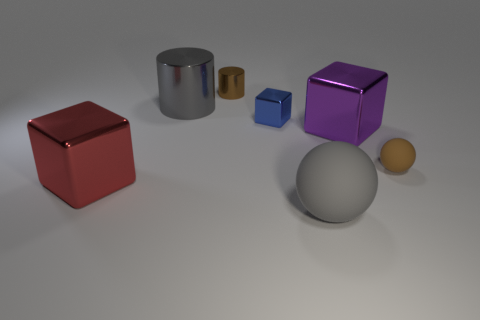What number of metal things are either tiny things or large brown cylinders?
Offer a terse response. 2. What number of other things are the same shape as the tiny blue object?
Ensure brevity in your answer.  2. What material is the large ball that is the same color as the big metallic cylinder?
Provide a succinct answer. Rubber. Do the shiny block that is in front of the tiny rubber object and the cylinder that is to the left of the tiny brown shiny object have the same size?
Provide a succinct answer. Yes. The rubber object behind the large gray matte ball has what shape?
Your response must be concise. Sphere. What is the material of the tiny brown thing that is the same shape as the big gray matte thing?
Give a very brief answer. Rubber. Is the size of the brown object that is in front of the blue shiny thing the same as the large gray ball?
Ensure brevity in your answer.  No. There is a red block; what number of blocks are behind it?
Make the answer very short. 2. Are there fewer small blue shiny objects in front of the big red metal object than big gray things that are right of the big purple thing?
Provide a succinct answer. No. What number of brown balls are there?
Offer a terse response. 1. 